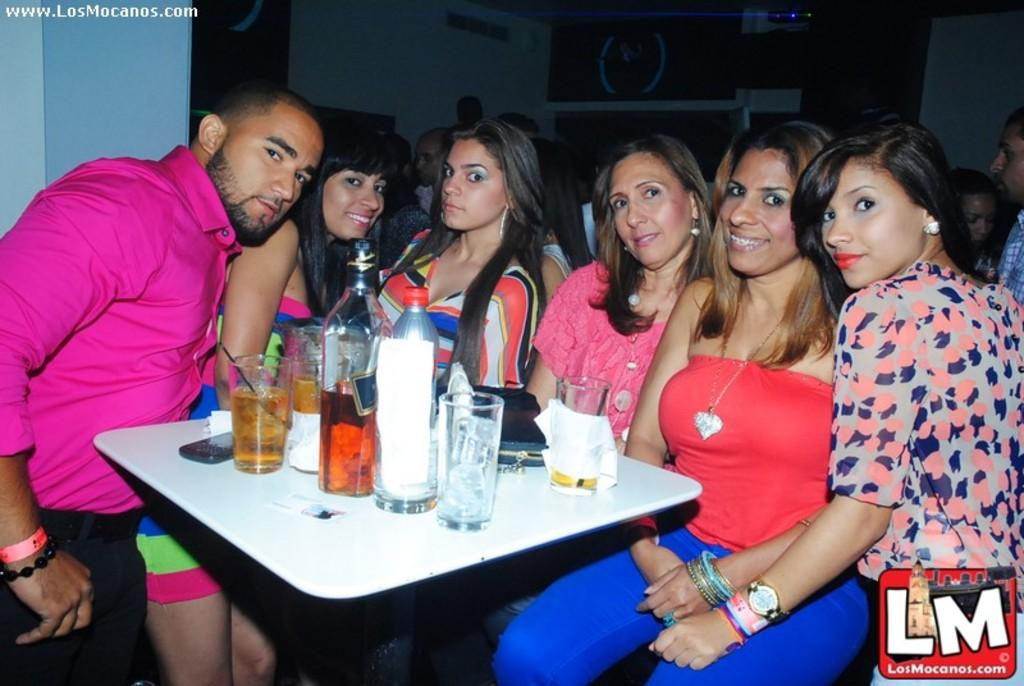What are the people near the table doing? There are people sitting near a table, and some are standing. What can be seen on the table? There are glasses with drinks, bottles, a mobile phone, a bag, and tissues on the table. What might be used for cleaning or wiping in the image? Tissues are present on the table for cleaning or wiping. What type of muscle is being exercised by the people in the image? There is no indication of any muscle exercise in the image; people are sitting or standing near a table. Is there a birthday celebration happening in the image? There is no indication of a birthday celebration in the image; it only shows people sitting or standing near a table with various items. 